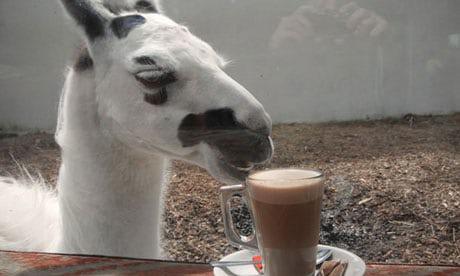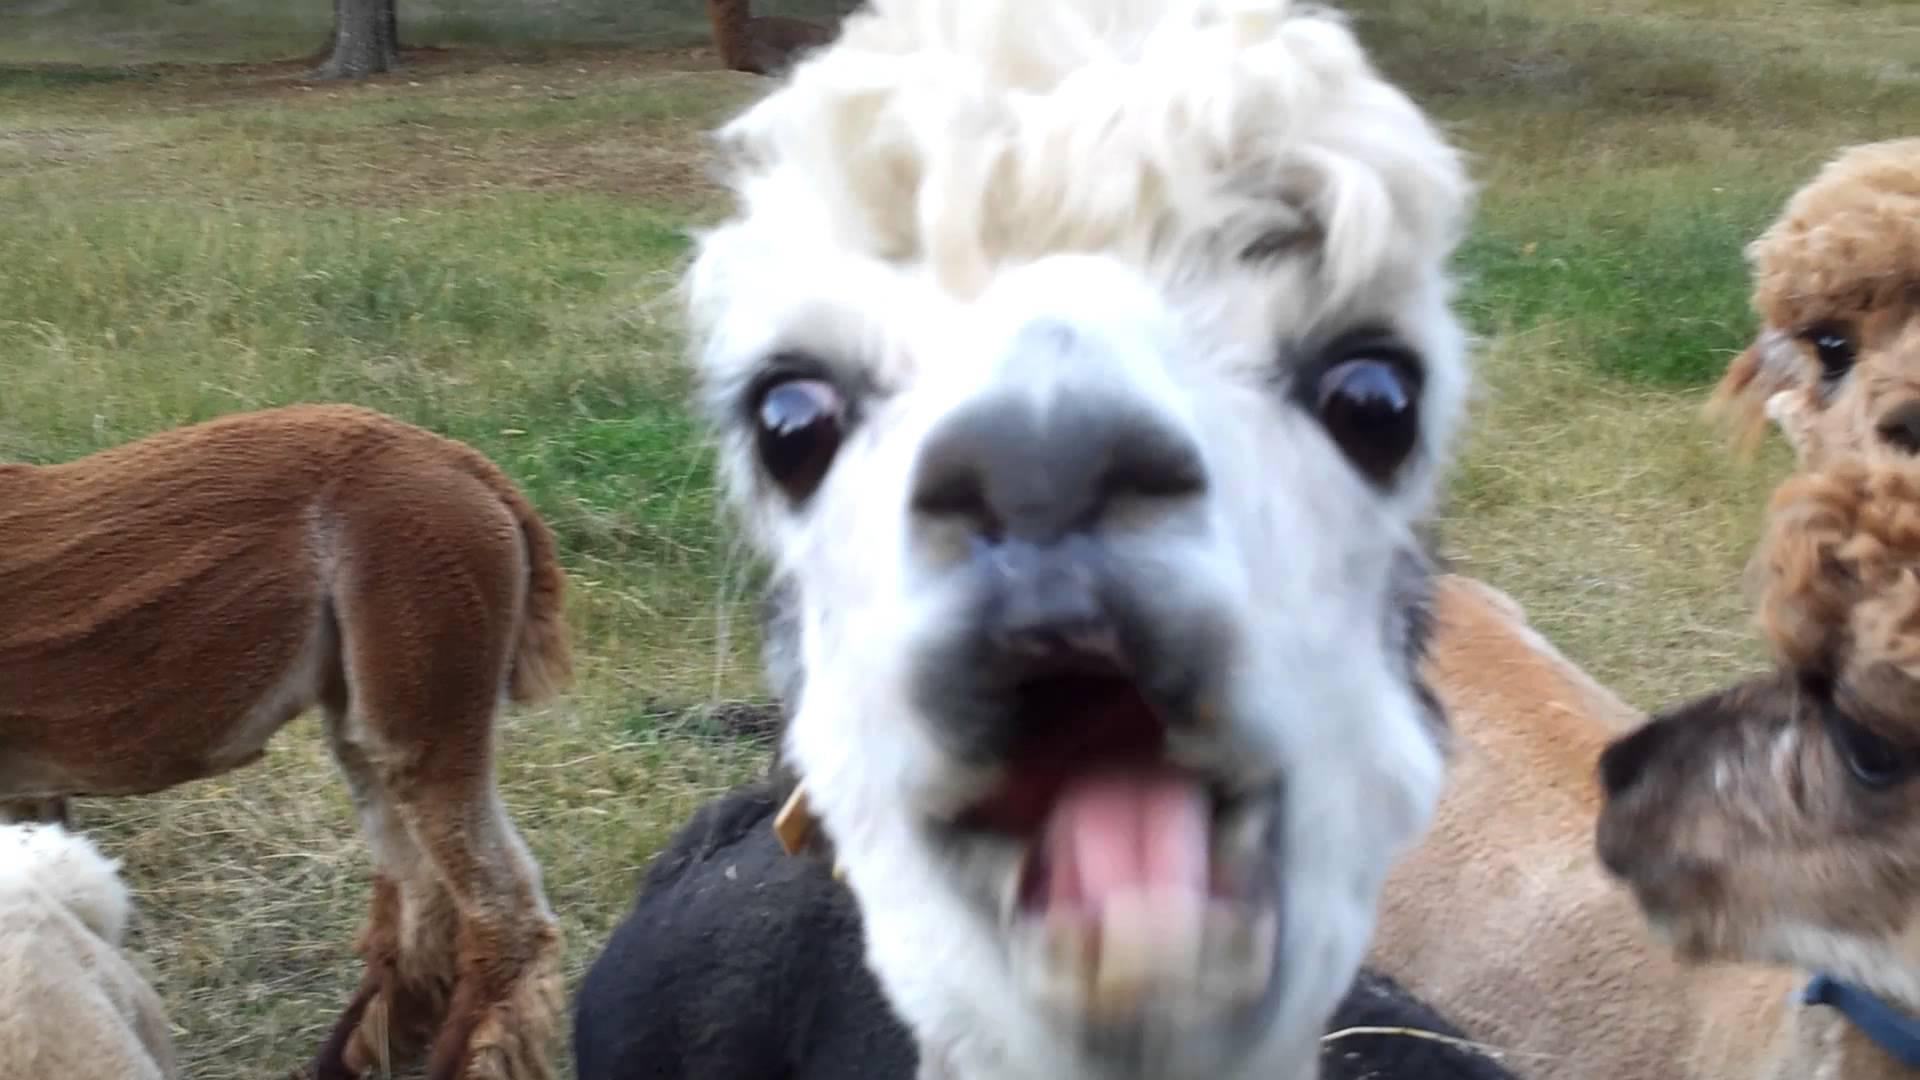The first image is the image on the left, the second image is the image on the right. Assess this claim about the two images: "In the right image, a pair of black-gloved hands are offering an apple to a white llama that is facing rightward.". Correct or not? Answer yes or no. No. The first image is the image on the left, the second image is the image on the right. Examine the images to the left and right. Is the description "A llama is being fed an apple." accurate? Answer yes or no. No. 